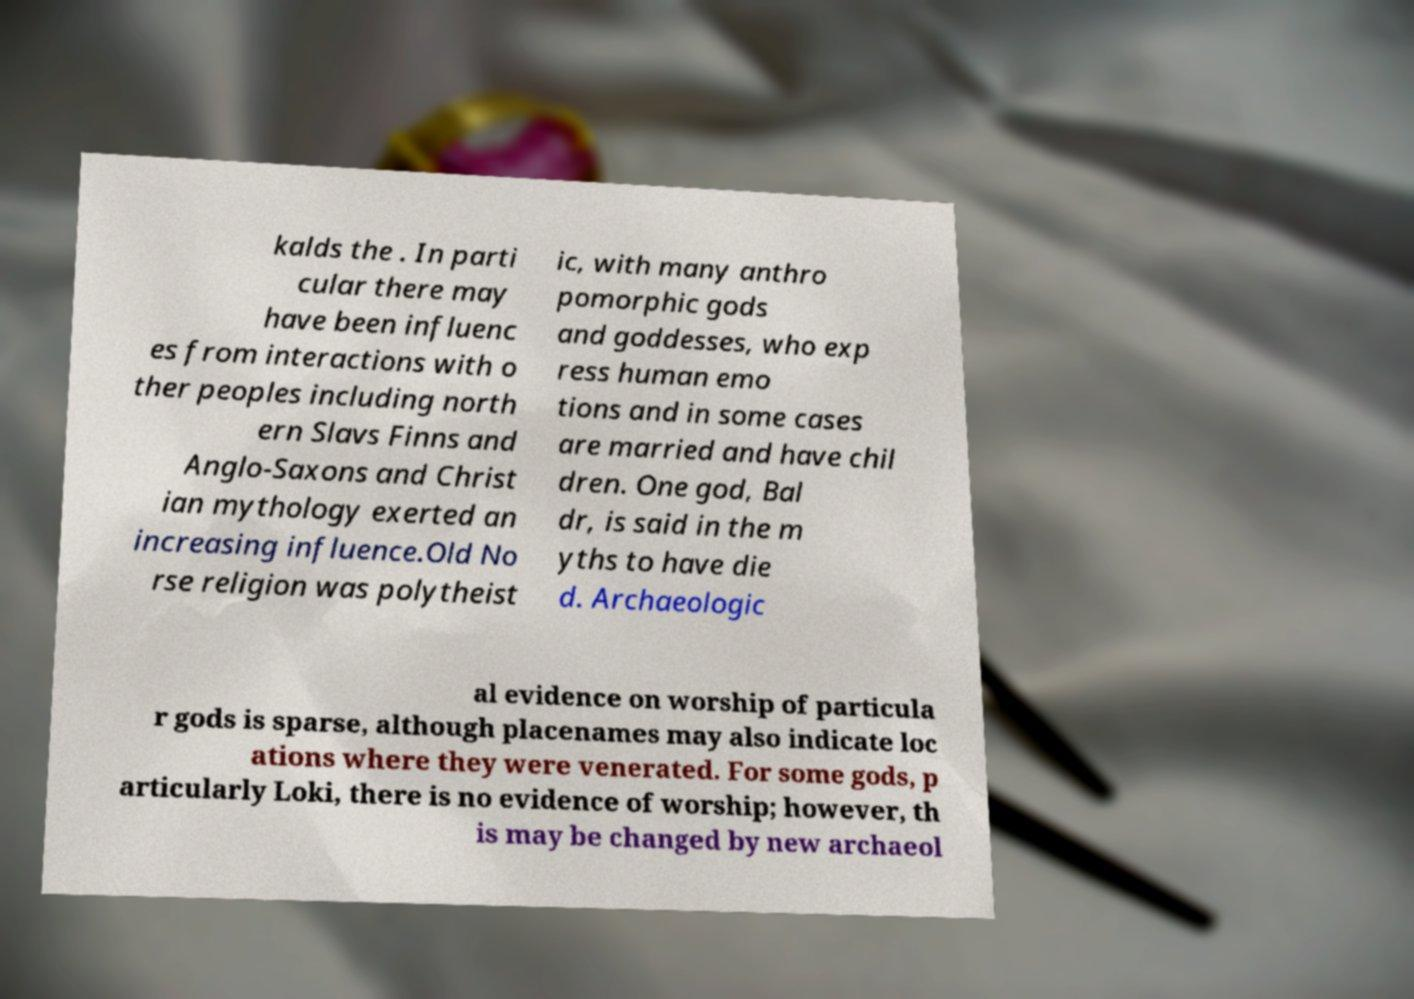There's text embedded in this image that I need extracted. Can you transcribe it verbatim? kalds the . In parti cular there may have been influenc es from interactions with o ther peoples including north ern Slavs Finns and Anglo-Saxons and Christ ian mythology exerted an increasing influence.Old No rse religion was polytheist ic, with many anthro pomorphic gods and goddesses, who exp ress human emo tions and in some cases are married and have chil dren. One god, Bal dr, is said in the m yths to have die d. Archaeologic al evidence on worship of particula r gods is sparse, although placenames may also indicate loc ations where they were venerated. For some gods, p articularly Loki, there is no evidence of worship; however, th is may be changed by new archaeol 